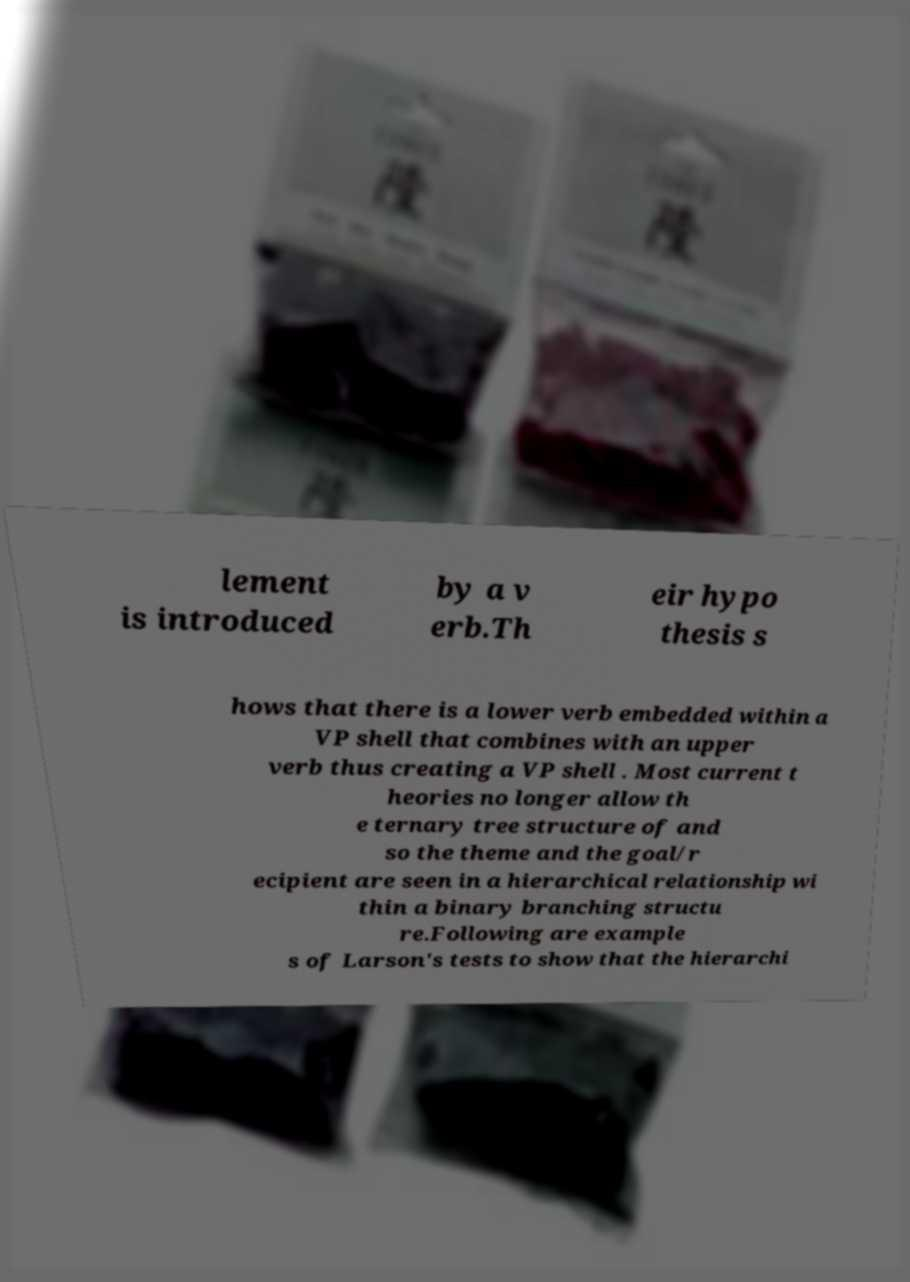What messages or text are displayed in this image? I need them in a readable, typed format. lement is introduced by a v erb.Th eir hypo thesis s hows that there is a lower verb embedded within a VP shell that combines with an upper verb thus creating a VP shell . Most current t heories no longer allow th e ternary tree structure of and so the theme and the goal/r ecipient are seen in a hierarchical relationship wi thin a binary branching structu re.Following are example s of Larson's tests to show that the hierarchi 